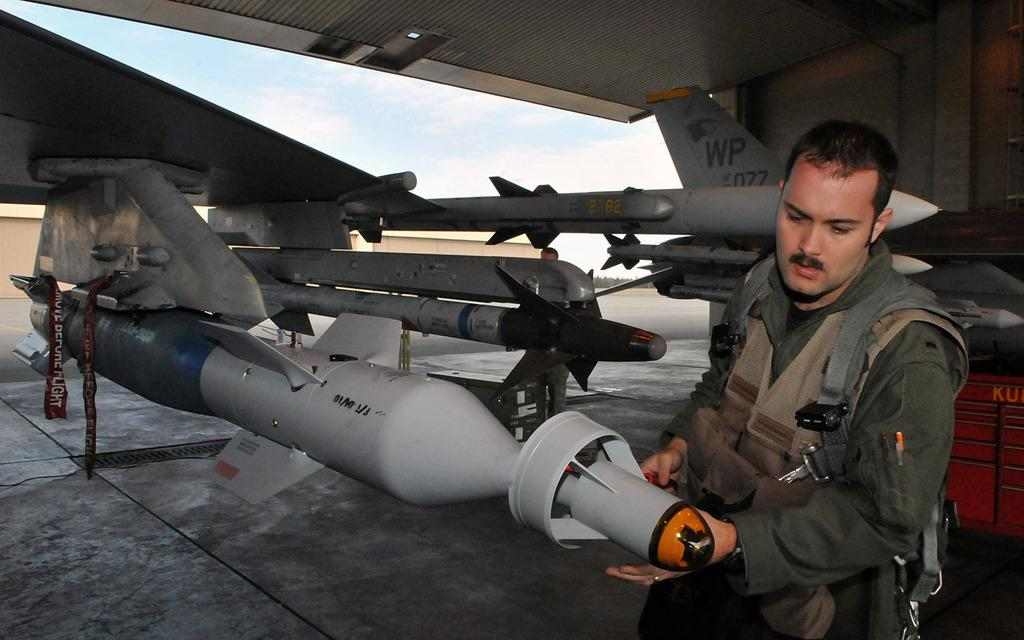What type of structure is present in the image? There is a shed in the image. What is located under the shed? Parts of an aeroplane are visible under the shed. Can you describe the people in the image? There are people present in the image. What object can be seen in the image? There is an object in the image, but the specific object is not mentioned in the facts. What can be seen in the background of the image? The sky and a wall are visible in the background of the image. How would you describe the sky in the image? The sky appears to be cloudy in the image. What type of wool is being spun by the people in the image? There is no wool or spinning activity present in the image. How many cans of paint are visible in the image? There is no mention of cans or paint in the image. 